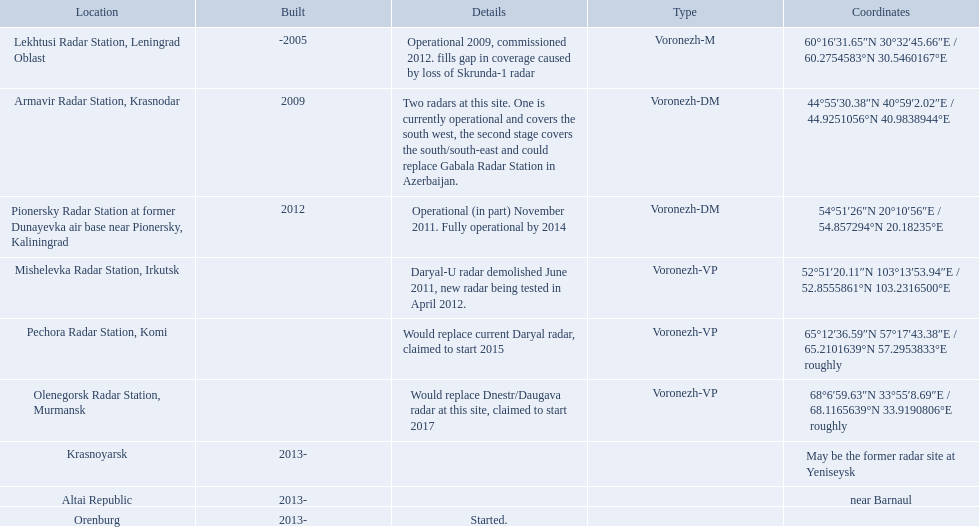What are all of the locations? Lekhtusi Radar Station, Leningrad Oblast, Armavir Radar Station, Krasnodar, Pionersky Radar Station at former Dunayevka air base near Pionersky, Kaliningrad, Mishelevka Radar Station, Irkutsk, Pechora Radar Station, Komi, Olenegorsk Radar Station, Murmansk, Krasnoyarsk, Altai Republic, Orenburg. And which location's coordinates are 60deg16'31.65''n 30deg32'45.66''e / 60.2754583degn 30.5460167dege? Lekhtusi Radar Station, Leningrad Oblast. Which column has the coordinates starting with 60 deg? 60°16′31.65″N 30°32′45.66″E﻿ / ﻿60.2754583°N 30.5460167°E. What is the location in the same row as that column? Lekhtusi Radar Station, Leningrad Oblast. 